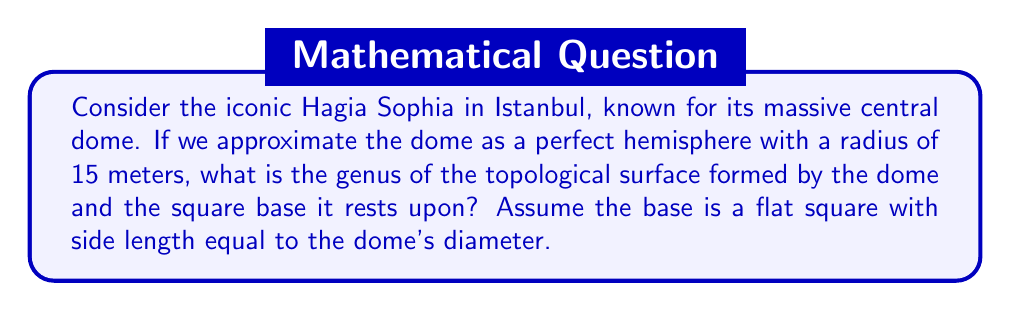Help me with this question. To solve this problem, we need to consider the topological properties of the structure:

1) First, let's visualize the structure:
   [asy]
   import three;
   size(200);
   currentprojection=perspective(6,3,2);
   
   // Draw the base
   draw((-15,-15,0)--(15,-15,0)--(15,15,0)--(-15,15,0)--cycle);
   
   // Draw the dome
   triple f(pair t) {return (15*cos(t.x)*cos(t.y),15*sin(t.x)*cos(t.y),15*sin(t.y));}
   surface s=surface(f,(0,0),(pi,pi/2),8,8,Spline);
   draw(s,paleblue);
   [/asy]

2) Topologically, this structure is equivalent to a sphere with a disk removed (the dome) attached to a disk (the base).

3) The genus of a surface is the number of "handles" it has. It can be calculated using the Euler characteristic $\chi$:

   $$\chi = 2 - 2g$$

   where $g$ is the genus.

4) For a sphere, $\chi = 2$. For a disk, $\chi = 1$.

5) When we attach the dome (sphere minus disk) to the base (disk), we're essentially gluing two surfaces along their boundaries. In this case, the Euler characteristic of the resulting surface is the sum of the Euler characteristics of the two parts:

   $$\chi_{total} = \chi_{sphere-disk} + \chi_{disk} = (2-1) + 1 = 2$$

6) Now we can solve for the genus:

   $$2 = 2 - 2g$$
   $$2g = 0$$
   $$g = 0$$
Answer: The genus of the topological surface formed by the dome and square base is 0. 